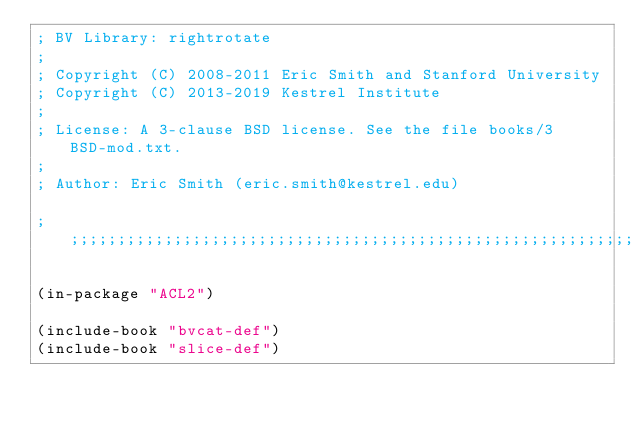<code> <loc_0><loc_0><loc_500><loc_500><_Lisp_>; BV Library: rightrotate
;
; Copyright (C) 2008-2011 Eric Smith and Stanford University
; Copyright (C) 2013-2019 Kestrel Institute
;
; License: A 3-clause BSD license. See the file books/3BSD-mod.txt.
;
; Author: Eric Smith (eric.smith@kestrel.edu)

;;;;;;;;;;;;;;;;;;;;;;;;;;;;;;;;;;;;;;;;;;;;;;;;;;;;;;;;;;;;;;;;;;;;;;;;;;;;;;;;

(in-package "ACL2")

(include-book "bvcat-def")
(include-book "slice-def")</code> 